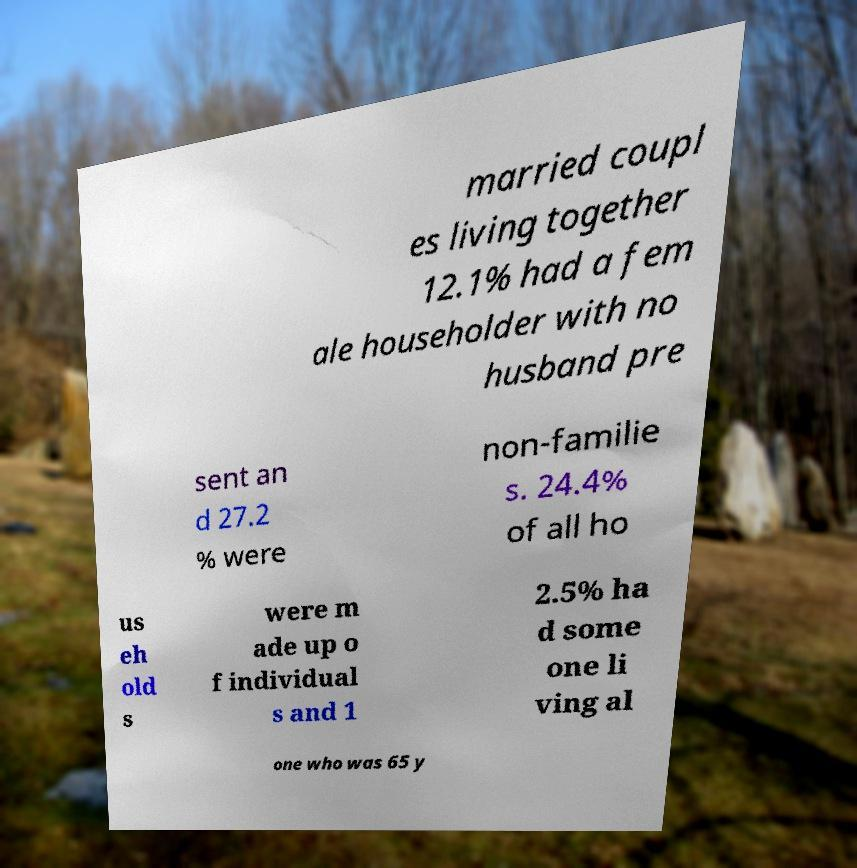Please identify and transcribe the text found in this image. married coupl es living together 12.1% had a fem ale householder with no husband pre sent an d 27.2 % were non-familie s. 24.4% of all ho us eh old s were m ade up o f individual s and 1 2.5% ha d some one li ving al one who was 65 y 